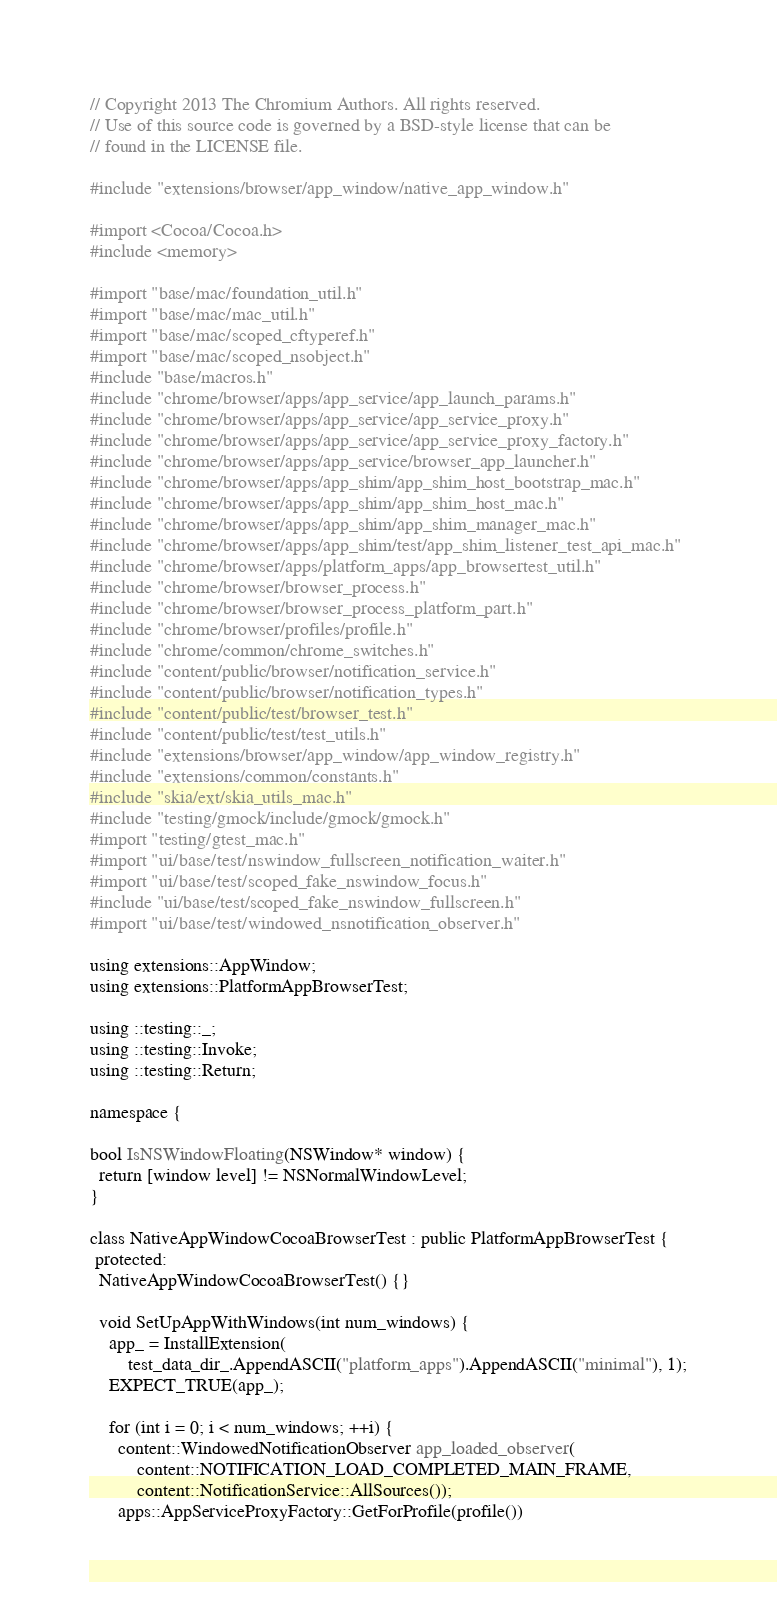Convert code to text. <code><loc_0><loc_0><loc_500><loc_500><_ObjectiveC_>// Copyright 2013 The Chromium Authors. All rights reserved.
// Use of this source code is governed by a BSD-style license that can be
// found in the LICENSE file.

#include "extensions/browser/app_window/native_app_window.h"

#import <Cocoa/Cocoa.h>
#include <memory>

#import "base/mac/foundation_util.h"
#import "base/mac/mac_util.h"
#import "base/mac/scoped_cftyperef.h"
#import "base/mac/scoped_nsobject.h"
#include "base/macros.h"
#include "chrome/browser/apps/app_service/app_launch_params.h"
#include "chrome/browser/apps/app_service/app_service_proxy.h"
#include "chrome/browser/apps/app_service/app_service_proxy_factory.h"
#include "chrome/browser/apps/app_service/browser_app_launcher.h"
#include "chrome/browser/apps/app_shim/app_shim_host_bootstrap_mac.h"
#include "chrome/browser/apps/app_shim/app_shim_host_mac.h"
#include "chrome/browser/apps/app_shim/app_shim_manager_mac.h"
#include "chrome/browser/apps/app_shim/test/app_shim_listener_test_api_mac.h"
#include "chrome/browser/apps/platform_apps/app_browsertest_util.h"
#include "chrome/browser/browser_process.h"
#include "chrome/browser/browser_process_platform_part.h"
#include "chrome/browser/profiles/profile.h"
#include "chrome/common/chrome_switches.h"
#include "content/public/browser/notification_service.h"
#include "content/public/browser/notification_types.h"
#include "content/public/test/browser_test.h"
#include "content/public/test/test_utils.h"
#include "extensions/browser/app_window/app_window_registry.h"
#include "extensions/common/constants.h"
#include "skia/ext/skia_utils_mac.h"
#include "testing/gmock/include/gmock/gmock.h"
#import "testing/gtest_mac.h"
#import "ui/base/test/nswindow_fullscreen_notification_waiter.h"
#import "ui/base/test/scoped_fake_nswindow_focus.h"
#include "ui/base/test/scoped_fake_nswindow_fullscreen.h"
#import "ui/base/test/windowed_nsnotification_observer.h"

using extensions::AppWindow;
using extensions::PlatformAppBrowserTest;

using ::testing::_;
using ::testing::Invoke;
using ::testing::Return;

namespace {

bool IsNSWindowFloating(NSWindow* window) {
  return [window level] != NSNormalWindowLevel;
}

class NativeAppWindowCocoaBrowserTest : public PlatformAppBrowserTest {
 protected:
  NativeAppWindowCocoaBrowserTest() {}

  void SetUpAppWithWindows(int num_windows) {
    app_ = InstallExtension(
        test_data_dir_.AppendASCII("platform_apps").AppendASCII("minimal"), 1);
    EXPECT_TRUE(app_);

    for (int i = 0; i < num_windows; ++i) {
      content::WindowedNotificationObserver app_loaded_observer(
          content::NOTIFICATION_LOAD_COMPLETED_MAIN_FRAME,
          content::NotificationService::AllSources());
      apps::AppServiceProxyFactory::GetForProfile(profile())</code> 